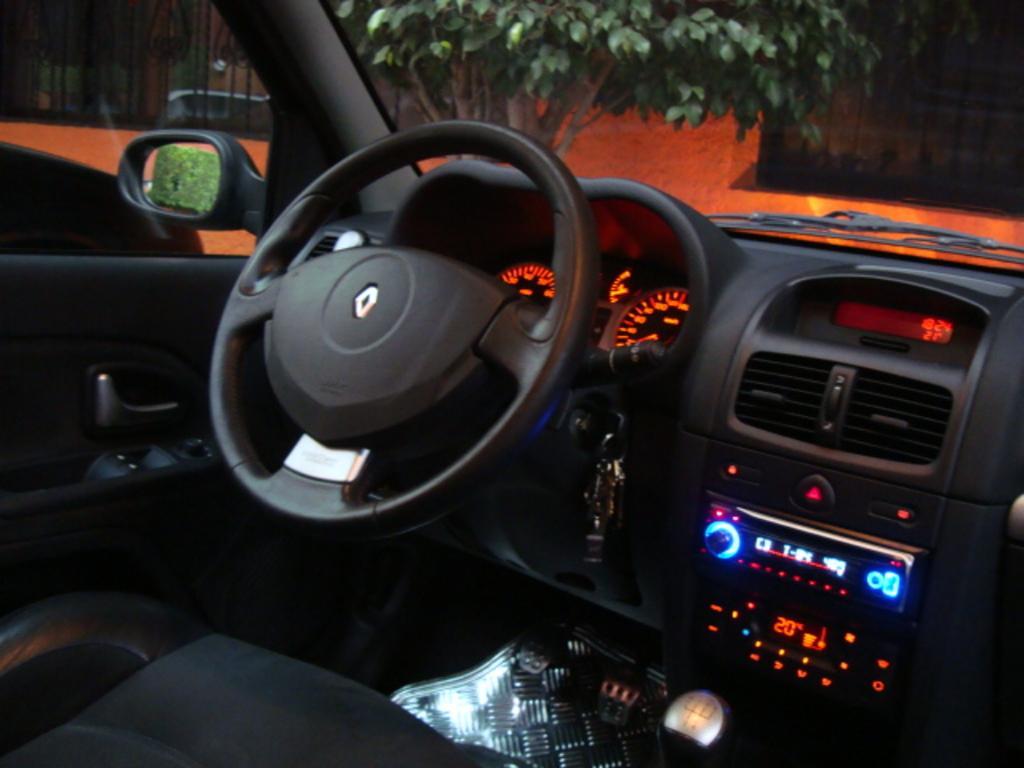Describe this image in one or two sentences. This image is clicked inside the car. There is steering, mirror, glass, wiper, speedometer, keys, brake, accelerator. 